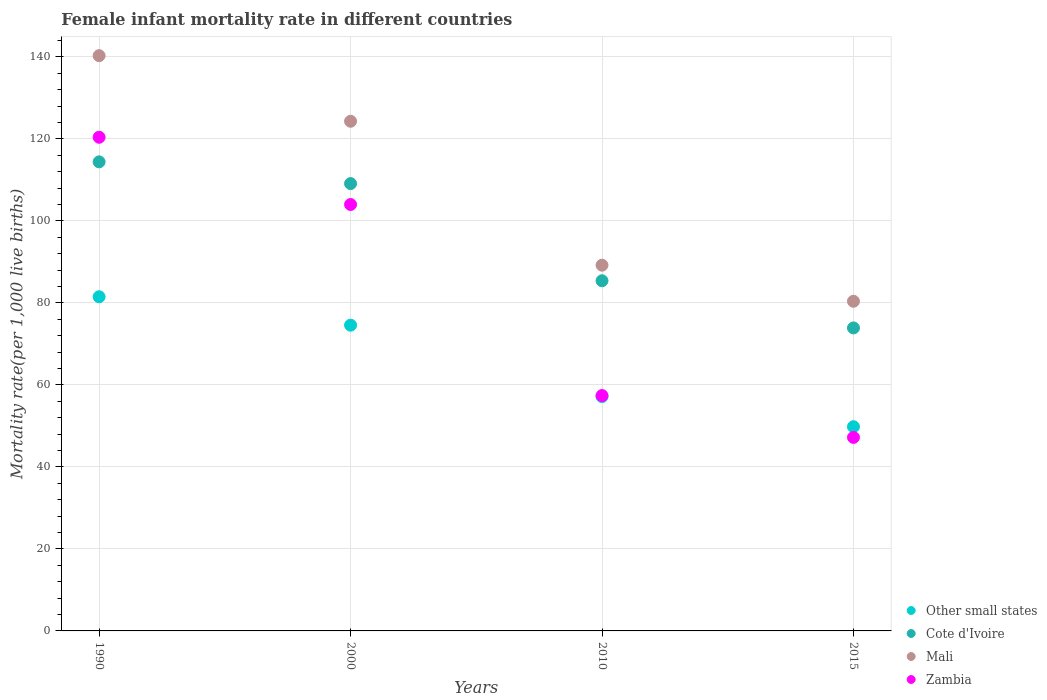What is the female infant mortality rate in Cote d'Ivoire in 2015?
Provide a succinct answer. 73.9. Across all years, what is the maximum female infant mortality rate in Zambia?
Offer a terse response. 120.4. Across all years, what is the minimum female infant mortality rate in Cote d'Ivoire?
Your answer should be compact. 73.9. In which year was the female infant mortality rate in Cote d'Ivoire minimum?
Your answer should be very brief. 2015. What is the total female infant mortality rate in Other small states in the graph?
Your response must be concise. 263.03. What is the difference between the female infant mortality rate in Mali in 1990 and that in 2015?
Your answer should be compact. 59.9. What is the difference between the female infant mortality rate in Other small states in 1990 and the female infant mortality rate in Zambia in 2010?
Offer a terse response. 24.1. What is the average female infant mortality rate in Cote d'Ivoire per year?
Give a very brief answer. 95.7. In the year 2010, what is the difference between the female infant mortality rate in Zambia and female infant mortality rate in Cote d'Ivoire?
Make the answer very short. -28. In how many years, is the female infant mortality rate in Cote d'Ivoire greater than 124?
Provide a succinct answer. 0. What is the ratio of the female infant mortality rate in Other small states in 2010 to that in 2015?
Provide a short and direct response. 1.15. Is the female infant mortality rate in Zambia in 1990 less than that in 2015?
Your response must be concise. No. Is the difference between the female infant mortality rate in Zambia in 1990 and 2015 greater than the difference between the female infant mortality rate in Cote d'Ivoire in 1990 and 2015?
Your answer should be compact. Yes. What is the difference between the highest and the second highest female infant mortality rate in Zambia?
Make the answer very short. 16.4. What is the difference between the highest and the lowest female infant mortality rate in Cote d'Ivoire?
Make the answer very short. 40.5. Is the sum of the female infant mortality rate in Other small states in 1990 and 2010 greater than the maximum female infant mortality rate in Mali across all years?
Provide a short and direct response. No. Is it the case that in every year, the sum of the female infant mortality rate in Mali and female infant mortality rate in Zambia  is greater than the sum of female infant mortality rate in Other small states and female infant mortality rate in Cote d'Ivoire?
Your response must be concise. No. Is it the case that in every year, the sum of the female infant mortality rate in Zambia and female infant mortality rate in Cote d'Ivoire  is greater than the female infant mortality rate in Mali?
Make the answer very short. Yes. Does the female infant mortality rate in Other small states monotonically increase over the years?
Provide a succinct answer. No. Is the female infant mortality rate in Other small states strictly greater than the female infant mortality rate in Cote d'Ivoire over the years?
Offer a very short reply. No. Is the female infant mortality rate in Mali strictly less than the female infant mortality rate in Cote d'Ivoire over the years?
Your answer should be very brief. No. How many dotlines are there?
Your answer should be very brief. 4. How many years are there in the graph?
Offer a terse response. 4. Where does the legend appear in the graph?
Your answer should be compact. Bottom right. How many legend labels are there?
Your response must be concise. 4. How are the legend labels stacked?
Provide a succinct answer. Vertical. What is the title of the graph?
Provide a succinct answer. Female infant mortality rate in different countries. What is the label or title of the X-axis?
Provide a short and direct response. Years. What is the label or title of the Y-axis?
Ensure brevity in your answer.  Mortality rate(per 1,0 live births). What is the Mortality rate(per 1,000 live births) of Other small states in 1990?
Your response must be concise. 81.5. What is the Mortality rate(per 1,000 live births) in Cote d'Ivoire in 1990?
Provide a short and direct response. 114.4. What is the Mortality rate(per 1,000 live births) of Mali in 1990?
Your answer should be very brief. 140.3. What is the Mortality rate(per 1,000 live births) in Zambia in 1990?
Provide a succinct answer. 120.4. What is the Mortality rate(per 1,000 live births) in Other small states in 2000?
Give a very brief answer. 74.57. What is the Mortality rate(per 1,000 live births) in Cote d'Ivoire in 2000?
Your response must be concise. 109.1. What is the Mortality rate(per 1,000 live births) of Mali in 2000?
Provide a short and direct response. 124.3. What is the Mortality rate(per 1,000 live births) in Zambia in 2000?
Make the answer very short. 104. What is the Mortality rate(per 1,000 live births) of Other small states in 2010?
Offer a terse response. 57.16. What is the Mortality rate(per 1,000 live births) in Cote d'Ivoire in 2010?
Make the answer very short. 85.4. What is the Mortality rate(per 1,000 live births) of Mali in 2010?
Offer a very short reply. 89.2. What is the Mortality rate(per 1,000 live births) of Zambia in 2010?
Your response must be concise. 57.4. What is the Mortality rate(per 1,000 live births) of Other small states in 2015?
Provide a short and direct response. 49.81. What is the Mortality rate(per 1,000 live births) of Cote d'Ivoire in 2015?
Make the answer very short. 73.9. What is the Mortality rate(per 1,000 live births) in Mali in 2015?
Your answer should be very brief. 80.4. What is the Mortality rate(per 1,000 live births) of Zambia in 2015?
Your response must be concise. 47.2. Across all years, what is the maximum Mortality rate(per 1,000 live births) in Other small states?
Your answer should be very brief. 81.5. Across all years, what is the maximum Mortality rate(per 1,000 live births) of Cote d'Ivoire?
Make the answer very short. 114.4. Across all years, what is the maximum Mortality rate(per 1,000 live births) in Mali?
Make the answer very short. 140.3. Across all years, what is the maximum Mortality rate(per 1,000 live births) of Zambia?
Keep it short and to the point. 120.4. Across all years, what is the minimum Mortality rate(per 1,000 live births) of Other small states?
Offer a terse response. 49.81. Across all years, what is the minimum Mortality rate(per 1,000 live births) in Cote d'Ivoire?
Your answer should be compact. 73.9. Across all years, what is the minimum Mortality rate(per 1,000 live births) of Mali?
Your response must be concise. 80.4. Across all years, what is the minimum Mortality rate(per 1,000 live births) of Zambia?
Provide a succinct answer. 47.2. What is the total Mortality rate(per 1,000 live births) of Other small states in the graph?
Keep it short and to the point. 263.03. What is the total Mortality rate(per 1,000 live births) in Cote d'Ivoire in the graph?
Your answer should be compact. 382.8. What is the total Mortality rate(per 1,000 live births) in Mali in the graph?
Your answer should be very brief. 434.2. What is the total Mortality rate(per 1,000 live births) in Zambia in the graph?
Offer a very short reply. 329. What is the difference between the Mortality rate(per 1,000 live births) of Other small states in 1990 and that in 2000?
Ensure brevity in your answer.  6.93. What is the difference between the Mortality rate(per 1,000 live births) of Cote d'Ivoire in 1990 and that in 2000?
Your response must be concise. 5.3. What is the difference between the Mortality rate(per 1,000 live births) in Other small states in 1990 and that in 2010?
Your response must be concise. 24.34. What is the difference between the Mortality rate(per 1,000 live births) in Cote d'Ivoire in 1990 and that in 2010?
Make the answer very short. 29. What is the difference between the Mortality rate(per 1,000 live births) of Mali in 1990 and that in 2010?
Make the answer very short. 51.1. What is the difference between the Mortality rate(per 1,000 live births) of Zambia in 1990 and that in 2010?
Give a very brief answer. 63. What is the difference between the Mortality rate(per 1,000 live births) of Other small states in 1990 and that in 2015?
Offer a very short reply. 31.69. What is the difference between the Mortality rate(per 1,000 live births) of Cote d'Ivoire in 1990 and that in 2015?
Give a very brief answer. 40.5. What is the difference between the Mortality rate(per 1,000 live births) in Mali in 1990 and that in 2015?
Offer a terse response. 59.9. What is the difference between the Mortality rate(per 1,000 live births) in Zambia in 1990 and that in 2015?
Your answer should be very brief. 73.2. What is the difference between the Mortality rate(per 1,000 live births) in Other small states in 2000 and that in 2010?
Your answer should be compact. 17.41. What is the difference between the Mortality rate(per 1,000 live births) in Cote d'Ivoire in 2000 and that in 2010?
Make the answer very short. 23.7. What is the difference between the Mortality rate(per 1,000 live births) of Mali in 2000 and that in 2010?
Make the answer very short. 35.1. What is the difference between the Mortality rate(per 1,000 live births) in Zambia in 2000 and that in 2010?
Keep it short and to the point. 46.6. What is the difference between the Mortality rate(per 1,000 live births) in Other small states in 2000 and that in 2015?
Ensure brevity in your answer.  24.76. What is the difference between the Mortality rate(per 1,000 live births) of Cote d'Ivoire in 2000 and that in 2015?
Give a very brief answer. 35.2. What is the difference between the Mortality rate(per 1,000 live births) of Mali in 2000 and that in 2015?
Ensure brevity in your answer.  43.9. What is the difference between the Mortality rate(per 1,000 live births) of Zambia in 2000 and that in 2015?
Provide a short and direct response. 56.8. What is the difference between the Mortality rate(per 1,000 live births) of Other small states in 2010 and that in 2015?
Provide a succinct answer. 7.35. What is the difference between the Mortality rate(per 1,000 live births) of Cote d'Ivoire in 2010 and that in 2015?
Keep it short and to the point. 11.5. What is the difference between the Mortality rate(per 1,000 live births) in Mali in 2010 and that in 2015?
Your response must be concise. 8.8. What is the difference between the Mortality rate(per 1,000 live births) in Other small states in 1990 and the Mortality rate(per 1,000 live births) in Cote d'Ivoire in 2000?
Ensure brevity in your answer.  -27.6. What is the difference between the Mortality rate(per 1,000 live births) of Other small states in 1990 and the Mortality rate(per 1,000 live births) of Mali in 2000?
Make the answer very short. -42.8. What is the difference between the Mortality rate(per 1,000 live births) of Other small states in 1990 and the Mortality rate(per 1,000 live births) of Zambia in 2000?
Offer a terse response. -22.5. What is the difference between the Mortality rate(per 1,000 live births) in Cote d'Ivoire in 1990 and the Mortality rate(per 1,000 live births) in Zambia in 2000?
Your response must be concise. 10.4. What is the difference between the Mortality rate(per 1,000 live births) in Mali in 1990 and the Mortality rate(per 1,000 live births) in Zambia in 2000?
Provide a succinct answer. 36.3. What is the difference between the Mortality rate(per 1,000 live births) in Other small states in 1990 and the Mortality rate(per 1,000 live births) in Cote d'Ivoire in 2010?
Offer a very short reply. -3.9. What is the difference between the Mortality rate(per 1,000 live births) of Other small states in 1990 and the Mortality rate(per 1,000 live births) of Mali in 2010?
Your response must be concise. -7.7. What is the difference between the Mortality rate(per 1,000 live births) of Other small states in 1990 and the Mortality rate(per 1,000 live births) of Zambia in 2010?
Ensure brevity in your answer.  24.1. What is the difference between the Mortality rate(per 1,000 live births) of Cote d'Ivoire in 1990 and the Mortality rate(per 1,000 live births) of Mali in 2010?
Your answer should be compact. 25.2. What is the difference between the Mortality rate(per 1,000 live births) of Cote d'Ivoire in 1990 and the Mortality rate(per 1,000 live births) of Zambia in 2010?
Make the answer very short. 57. What is the difference between the Mortality rate(per 1,000 live births) in Mali in 1990 and the Mortality rate(per 1,000 live births) in Zambia in 2010?
Your answer should be very brief. 82.9. What is the difference between the Mortality rate(per 1,000 live births) of Other small states in 1990 and the Mortality rate(per 1,000 live births) of Cote d'Ivoire in 2015?
Your answer should be very brief. 7.6. What is the difference between the Mortality rate(per 1,000 live births) in Other small states in 1990 and the Mortality rate(per 1,000 live births) in Mali in 2015?
Your response must be concise. 1.1. What is the difference between the Mortality rate(per 1,000 live births) of Other small states in 1990 and the Mortality rate(per 1,000 live births) of Zambia in 2015?
Make the answer very short. 34.3. What is the difference between the Mortality rate(per 1,000 live births) of Cote d'Ivoire in 1990 and the Mortality rate(per 1,000 live births) of Zambia in 2015?
Provide a succinct answer. 67.2. What is the difference between the Mortality rate(per 1,000 live births) of Mali in 1990 and the Mortality rate(per 1,000 live births) of Zambia in 2015?
Offer a very short reply. 93.1. What is the difference between the Mortality rate(per 1,000 live births) of Other small states in 2000 and the Mortality rate(per 1,000 live births) of Cote d'Ivoire in 2010?
Provide a succinct answer. -10.83. What is the difference between the Mortality rate(per 1,000 live births) in Other small states in 2000 and the Mortality rate(per 1,000 live births) in Mali in 2010?
Ensure brevity in your answer.  -14.63. What is the difference between the Mortality rate(per 1,000 live births) in Other small states in 2000 and the Mortality rate(per 1,000 live births) in Zambia in 2010?
Provide a short and direct response. 17.17. What is the difference between the Mortality rate(per 1,000 live births) of Cote d'Ivoire in 2000 and the Mortality rate(per 1,000 live births) of Zambia in 2010?
Offer a terse response. 51.7. What is the difference between the Mortality rate(per 1,000 live births) in Mali in 2000 and the Mortality rate(per 1,000 live births) in Zambia in 2010?
Provide a succinct answer. 66.9. What is the difference between the Mortality rate(per 1,000 live births) of Other small states in 2000 and the Mortality rate(per 1,000 live births) of Cote d'Ivoire in 2015?
Provide a succinct answer. 0.67. What is the difference between the Mortality rate(per 1,000 live births) of Other small states in 2000 and the Mortality rate(per 1,000 live births) of Mali in 2015?
Ensure brevity in your answer.  -5.83. What is the difference between the Mortality rate(per 1,000 live births) of Other small states in 2000 and the Mortality rate(per 1,000 live births) of Zambia in 2015?
Offer a very short reply. 27.37. What is the difference between the Mortality rate(per 1,000 live births) in Cote d'Ivoire in 2000 and the Mortality rate(per 1,000 live births) in Mali in 2015?
Your response must be concise. 28.7. What is the difference between the Mortality rate(per 1,000 live births) in Cote d'Ivoire in 2000 and the Mortality rate(per 1,000 live births) in Zambia in 2015?
Provide a succinct answer. 61.9. What is the difference between the Mortality rate(per 1,000 live births) of Mali in 2000 and the Mortality rate(per 1,000 live births) of Zambia in 2015?
Offer a very short reply. 77.1. What is the difference between the Mortality rate(per 1,000 live births) of Other small states in 2010 and the Mortality rate(per 1,000 live births) of Cote d'Ivoire in 2015?
Offer a terse response. -16.74. What is the difference between the Mortality rate(per 1,000 live births) of Other small states in 2010 and the Mortality rate(per 1,000 live births) of Mali in 2015?
Offer a terse response. -23.24. What is the difference between the Mortality rate(per 1,000 live births) of Other small states in 2010 and the Mortality rate(per 1,000 live births) of Zambia in 2015?
Provide a succinct answer. 9.96. What is the difference between the Mortality rate(per 1,000 live births) in Cote d'Ivoire in 2010 and the Mortality rate(per 1,000 live births) in Zambia in 2015?
Offer a terse response. 38.2. What is the average Mortality rate(per 1,000 live births) in Other small states per year?
Your answer should be very brief. 65.76. What is the average Mortality rate(per 1,000 live births) in Cote d'Ivoire per year?
Keep it short and to the point. 95.7. What is the average Mortality rate(per 1,000 live births) of Mali per year?
Give a very brief answer. 108.55. What is the average Mortality rate(per 1,000 live births) of Zambia per year?
Your answer should be compact. 82.25. In the year 1990, what is the difference between the Mortality rate(per 1,000 live births) of Other small states and Mortality rate(per 1,000 live births) of Cote d'Ivoire?
Provide a short and direct response. -32.9. In the year 1990, what is the difference between the Mortality rate(per 1,000 live births) of Other small states and Mortality rate(per 1,000 live births) of Mali?
Give a very brief answer. -58.8. In the year 1990, what is the difference between the Mortality rate(per 1,000 live births) in Other small states and Mortality rate(per 1,000 live births) in Zambia?
Your answer should be very brief. -38.9. In the year 1990, what is the difference between the Mortality rate(per 1,000 live births) in Cote d'Ivoire and Mortality rate(per 1,000 live births) in Mali?
Provide a short and direct response. -25.9. In the year 2000, what is the difference between the Mortality rate(per 1,000 live births) of Other small states and Mortality rate(per 1,000 live births) of Cote d'Ivoire?
Provide a succinct answer. -34.53. In the year 2000, what is the difference between the Mortality rate(per 1,000 live births) of Other small states and Mortality rate(per 1,000 live births) of Mali?
Your answer should be compact. -49.73. In the year 2000, what is the difference between the Mortality rate(per 1,000 live births) of Other small states and Mortality rate(per 1,000 live births) of Zambia?
Give a very brief answer. -29.43. In the year 2000, what is the difference between the Mortality rate(per 1,000 live births) of Cote d'Ivoire and Mortality rate(per 1,000 live births) of Mali?
Your answer should be very brief. -15.2. In the year 2000, what is the difference between the Mortality rate(per 1,000 live births) of Cote d'Ivoire and Mortality rate(per 1,000 live births) of Zambia?
Offer a terse response. 5.1. In the year 2000, what is the difference between the Mortality rate(per 1,000 live births) in Mali and Mortality rate(per 1,000 live births) in Zambia?
Give a very brief answer. 20.3. In the year 2010, what is the difference between the Mortality rate(per 1,000 live births) in Other small states and Mortality rate(per 1,000 live births) in Cote d'Ivoire?
Provide a succinct answer. -28.24. In the year 2010, what is the difference between the Mortality rate(per 1,000 live births) of Other small states and Mortality rate(per 1,000 live births) of Mali?
Your answer should be very brief. -32.04. In the year 2010, what is the difference between the Mortality rate(per 1,000 live births) in Other small states and Mortality rate(per 1,000 live births) in Zambia?
Provide a succinct answer. -0.24. In the year 2010, what is the difference between the Mortality rate(per 1,000 live births) of Cote d'Ivoire and Mortality rate(per 1,000 live births) of Zambia?
Give a very brief answer. 28. In the year 2010, what is the difference between the Mortality rate(per 1,000 live births) in Mali and Mortality rate(per 1,000 live births) in Zambia?
Keep it short and to the point. 31.8. In the year 2015, what is the difference between the Mortality rate(per 1,000 live births) in Other small states and Mortality rate(per 1,000 live births) in Cote d'Ivoire?
Provide a succinct answer. -24.09. In the year 2015, what is the difference between the Mortality rate(per 1,000 live births) in Other small states and Mortality rate(per 1,000 live births) in Mali?
Give a very brief answer. -30.59. In the year 2015, what is the difference between the Mortality rate(per 1,000 live births) of Other small states and Mortality rate(per 1,000 live births) of Zambia?
Your answer should be compact. 2.61. In the year 2015, what is the difference between the Mortality rate(per 1,000 live births) in Cote d'Ivoire and Mortality rate(per 1,000 live births) in Mali?
Give a very brief answer. -6.5. In the year 2015, what is the difference between the Mortality rate(per 1,000 live births) in Cote d'Ivoire and Mortality rate(per 1,000 live births) in Zambia?
Your answer should be compact. 26.7. In the year 2015, what is the difference between the Mortality rate(per 1,000 live births) in Mali and Mortality rate(per 1,000 live births) in Zambia?
Make the answer very short. 33.2. What is the ratio of the Mortality rate(per 1,000 live births) in Other small states in 1990 to that in 2000?
Provide a short and direct response. 1.09. What is the ratio of the Mortality rate(per 1,000 live births) of Cote d'Ivoire in 1990 to that in 2000?
Give a very brief answer. 1.05. What is the ratio of the Mortality rate(per 1,000 live births) in Mali in 1990 to that in 2000?
Your answer should be compact. 1.13. What is the ratio of the Mortality rate(per 1,000 live births) of Zambia in 1990 to that in 2000?
Keep it short and to the point. 1.16. What is the ratio of the Mortality rate(per 1,000 live births) in Other small states in 1990 to that in 2010?
Ensure brevity in your answer.  1.43. What is the ratio of the Mortality rate(per 1,000 live births) of Cote d'Ivoire in 1990 to that in 2010?
Your answer should be very brief. 1.34. What is the ratio of the Mortality rate(per 1,000 live births) of Mali in 1990 to that in 2010?
Make the answer very short. 1.57. What is the ratio of the Mortality rate(per 1,000 live births) of Zambia in 1990 to that in 2010?
Give a very brief answer. 2.1. What is the ratio of the Mortality rate(per 1,000 live births) of Other small states in 1990 to that in 2015?
Keep it short and to the point. 1.64. What is the ratio of the Mortality rate(per 1,000 live births) in Cote d'Ivoire in 1990 to that in 2015?
Offer a terse response. 1.55. What is the ratio of the Mortality rate(per 1,000 live births) of Mali in 1990 to that in 2015?
Offer a terse response. 1.75. What is the ratio of the Mortality rate(per 1,000 live births) of Zambia in 1990 to that in 2015?
Ensure brevity in your answer.  2.55. What is the ratio of the Mortality rate(per 1,000 live births) of Other small states in 2000 to that in 2010?
Your answer should be compact. 1.3. What is the ratio of the Mortality rate(per 1,000 live births) of Cote d'Ivoire in 2000 to that in 2010?
Offer a very short reply. 1.28. What is the ratio of the Mortality rate(per 1,000 live births) in Mali in 2000 to that in 2010?
Your answer should be compact. 1.39. What is the ratio of the Mortality rate(per 1,000 live births) of Zambia in 2000 to that in 2010?
Keep it short and to the point. 1.81. What is the ratio of the Mortality rate(per 1,000 live births) of Other small states in 2000 to that in 2015?
Offer a terse response. 1.5. What is the ratio of the Mortality rate(per 1,000 live births) of Cote d'Ivoire in 2000 to that in 2015?
Your answer should be very brief. 1.48. What is the ratio of the Mortality rate(per 1,000 live births) of Mali in 2000 to that in 2015?
Your answer should be very brief. 1.55. What is the ratio of the Mortality rate(per 1,000 live births) of Zambia in 2000 to that in 2015?
Give a very brief answer. 2.2. What is the ratio of the Mortality rate(per 1,000 live births) of Other small states in 2010 to that in 2015?
Provide a short and direct response. 1.15. What is the ratio of the Mortality rate(per 1,000 live births) of Cote d'Ivoire in 2010 to that in 2015?
Your response must be concise. 1.16. What is the ratio of the Mortality rate(per 1,000 live births) of Mali in 2010 to that in 2015?
Give a very brief answer. 1.11. What is the ratio of the Mortality rate(per 1,000 live births) of Zambia in 2010 to that in 2015?
Ensure brevity in your answer.  1.22. What is the difference between the highest and the second highest Mortality rate(per 1,000 live births) of Other small states?
Give a very brief answer. 6.93. What is the difference between the highest and the second highest Mortality rate(per 1,000 live births) of Mali?
Provide a succinct answer. 16. What is the difference between the highest and the second highest Mortality rate(per 1,000 live births) in Zambia?
Make the answer very short. 16.4. What is the difference between the highest and the lowest Mortality rate(per 1,000 live births) in Other small states?
Offer a very short reply. 31.69. What is the difference between the highest and the lowest Mortality rate(per 1,000 live births) of Cote d'Ivoire?
Offer a very short reply. 40.5. What is the difference between the highest and the lowest Mortality rate(per 1,000 live births) of Mali?
Provide a short and direct response. 59.9. What is the difference between the highest and the lowest Mortality rate(per 1,000 live births) of Zambia?
Your answer should be compact. 73.2. 